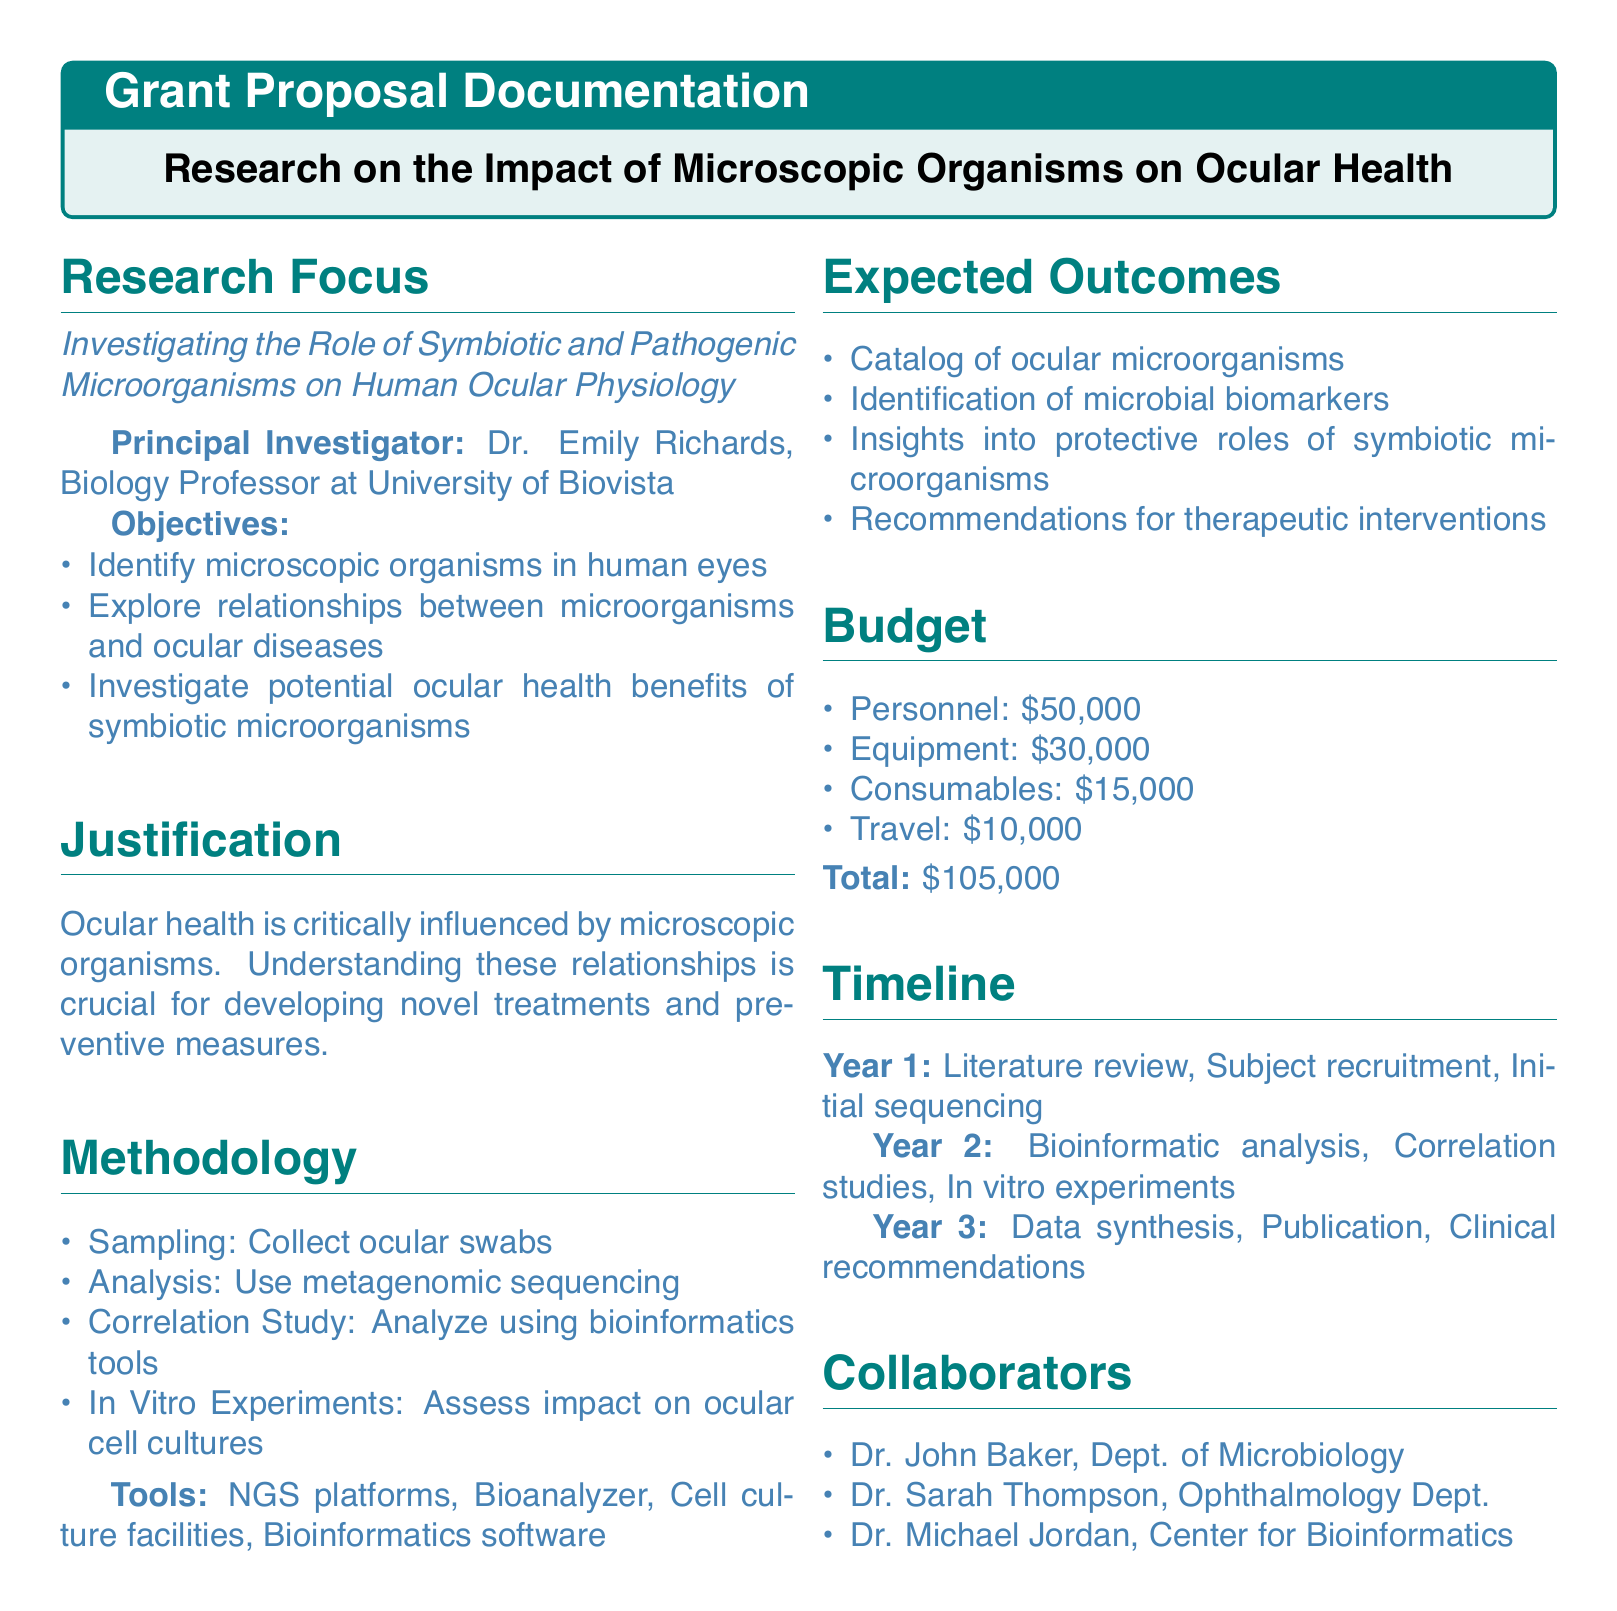What is the title of the research project? The title of the research project is given in the document as "Research on the Impact of Microscopic Organisms on Ocular Health."
Answer: Research on the Impact of Microscopic Organisms on Ocular Health Who is the Principal Investigator? The Principal Investigator responsible for the project is named in the document as Dr. Emily Richards.
Answer: Dr. Emily Richards What is the total budget for the research? The total budget for the research is explicitly stated in the document, which sums all the budgetary components.
Answer: $105,000 Which year will the initial sequencing occur? The timeline specifies activities for Year 1, including initial sequencing, which helps identify when this activity is scheduled.
Answer: Year 1 Name one collaborator from the Department of Microbiology. The document lists collaborators and specifies one from the Department of Microbiology, allowing us to identify them easily.
Answer: Dr. John Baker What is the primary focus of the research? The research focus is outlined in the document, detailing the main theme or subject of the investigation.
Answer: Investigating the Role of Symbiotic and Pathogenic Microorganisms on Human Ocular Physiology Which methodology involves analyzing eye swabs? The method specifically related to ocular swabs is part of the methodology section in the document, indicating its significance in the research process.
Answer: Sampling How much is allocated for personnel in the budget? The budget section clearly states the amount designated for personnel, contributing to the overall funding breakdown.
Answer: $50,000 